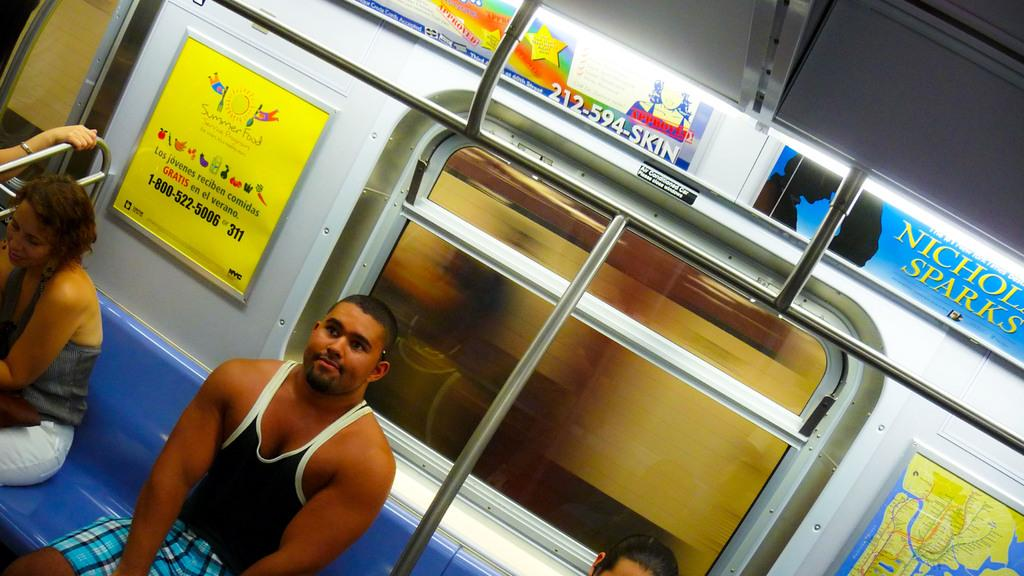<image>
Write a terse but informative summary of the picture. A man sits near a "summer food" sign on the subway 